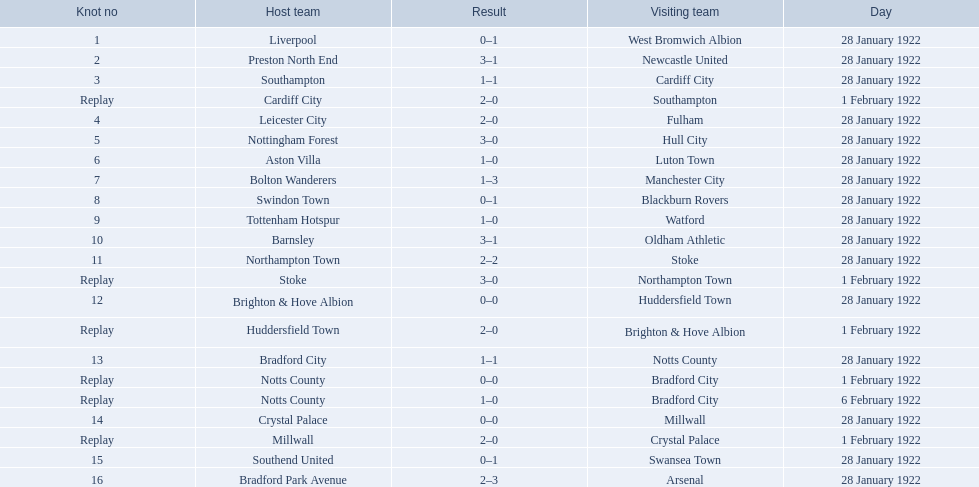What are all of the home teams? Liverpool, Preston North End, Southampton, Cardiff City, Leicester City, Nottingham Forest, Aston Villa, Bolton Wanderers, Swindon Town, Tottenham Hotspur, Barnsley, Northampton Town, Stoke, Brighton & Hove Albion, Huddersfield Town, Bradford City, Notts County, Notts County, Crystal Palace, Millwall, Southend United, Bradford Park Avenue. What were the scores? 0–1, 3–1, 1–1, 2–0, 2–0, 3–0, 1–0, 1–3, 0–1, 1–0, 3–1, 2–2, 3–0, 0–0, 2–0, 1–1, 0–0, 1–0, 0–0, 2–0, 0–1, 2–3. On which dates did they play? 28 January 1922, 28 January 1922, 28 January 1922, 1 February 1922, 28 January 1922, 28 January 1922, 28 January 1922, 28 January 1922, 28 January 1922, 28 January 1922, 28 January 1922, 28 January 1922, 1 February 1922, 28 January 1922, 1 February 1922, 28 January 1922, 1 February 1922, 6 February 1922, 28 January 1922, 1 February 1922, 28 January 1922, 28 January 1922. Which teams played on 28 january 1922? Liverpool, Preston North End, Southampton, Leicester City, Nottingham Forest, Aston Villa, Bolton Wanderers, Swindon Town, Tottenham Hotspur, Barnsley, Northampton Town, Brighton & Hove Albion, Bradford City, Crystal Palace, Southend United, Bradford Park Avenue. Of those, which scored the same as aston villa? Tottenham Hotspur. 